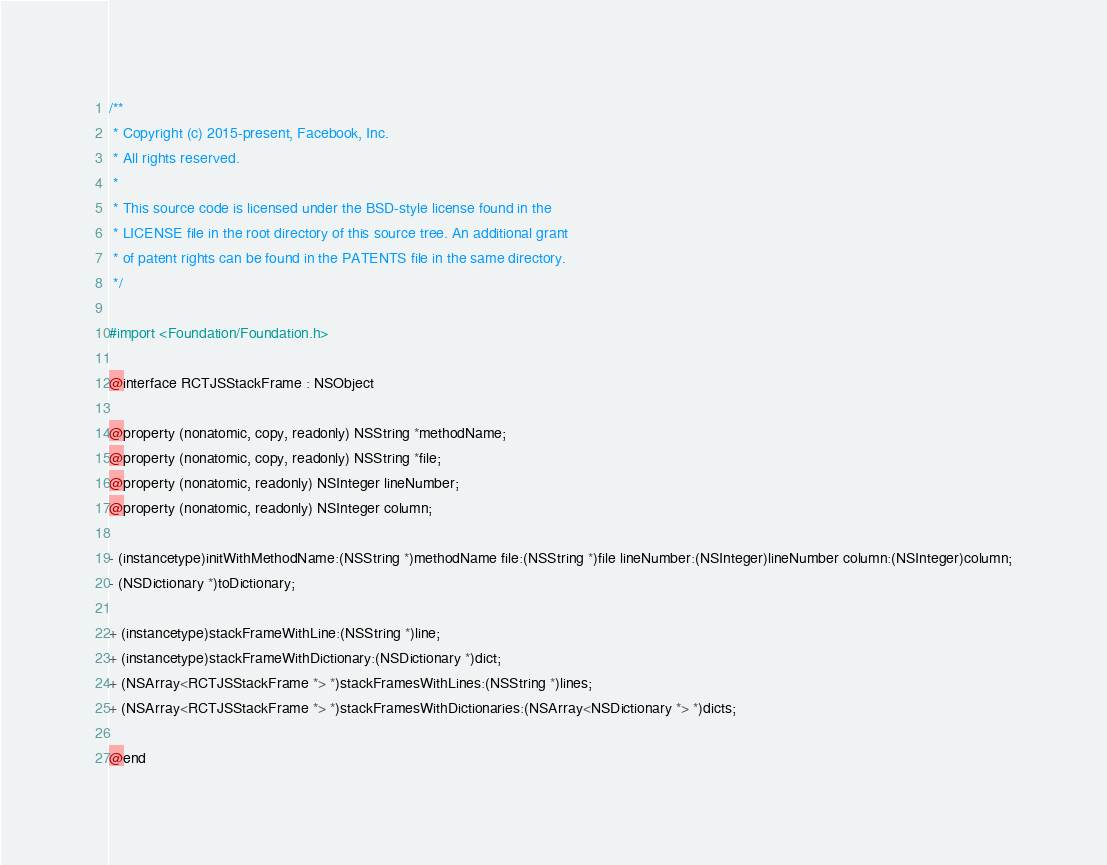<code> <loc_0><loc_0><loc_500><loc_500><_C_>/**
 * Copyright (c) 2015-present, Facebook, Inc.
 * All rights reserved.
 *
 * This source code is licensed under the BSD-style license found in the
 * LICENSE file in the root directory of this source tree. An additional grant
 * of patent rights can be found in the PATENTS file in the same directory.
 */

#import <Foundation/Foundation.h>

@interface RCTJSStackFrame : NSObject

@property (nonatomic, copy, readonly) NSString *methodName;
@property (nonatomic, copy, readonly) NSString *file;
@property (nonatomic, readonly) NSInteger lineNumber;
@property (nonatomic, readonly) NSInteger column;

- (instancetype)initWithMethodName:(NSString *)methodName file:(NSString *)file lineNumber:(NSInteger)lineNumber column:(NSInteger)column;
- (NSDictionary *)toDictionary;

+ (instancetype)stackFrameWithLine:(NSString *)line;
+ (instancetype)stackFrameWithDictionary:(NSDictionary *)dict;
+ (NSArray<RCTJSStackFrame *> *)stackFramesWithLines:(NSString *)lines;
+ (NSArray<RCTJSStackFrame *> *)stackFramesWithDictionaries:(NSArray<NSDictionary *> *)dicts;

@end
</code> 